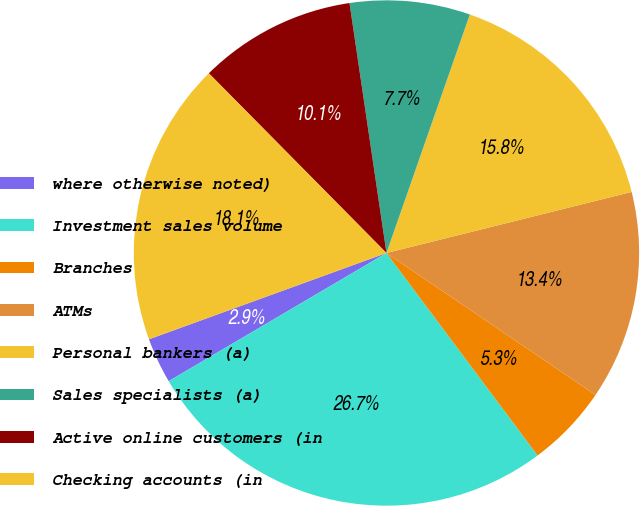<chart> <loc_0><loc_0><loc_500><loc_500><pie_chart><fcel>where otherwise noted)<fcel>Investment sales volume<fcel>Branches<fcel>ATMs<fcel>Personal bankers (a)<fcel>Sales specialists (a)<fcel>Active online customers (in<fcel>Checking accounts (in<nl><fcel>2.92%<fcel>26.74%<fcel>5.3%<fcel>13.38%<fcel>15.76%<fcel>7.69%<fcel>10.07%<fcel>18.14%<nl></chart> 